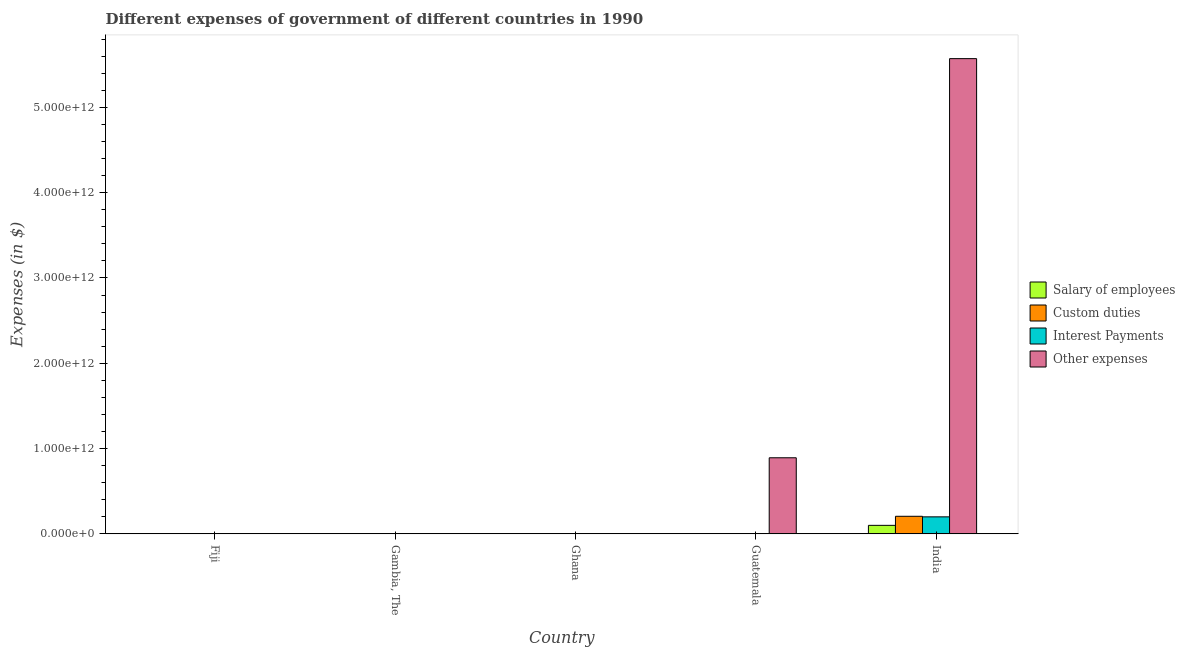How many different coloured bars are there?
Provide a succinct answer. 4. Are the number of bars per tick equal to the number of legend labels?
Offer a very short reply. Yes. How many bars are there on the 4th tick from the right?
Make the answer very short. 4. What is the label of the 1st group of bars from the left?
Offer a very short reply. Fiji. In how many cases, is the number of bars for a given country not equal to the number of legend labels?
Your answer should be very brief. 0. What is the amount spent on interest payments in Fiji?
Give a very brief answer. 6.85e+07. Across all countries, what is the maximum amount spent on salary of employees?
Keep it short and to the point. 9.97e+1. Across all countries, what is the minimum amount spent on custom duties?
Ensure brevity in your answer.  6.31e+06. In which country was the amount spent on salary of employees maximum?
Provide a short and direct response. India. What is the total amount spent on other expenses in the graph?
Your answer should be very brief. 6.47e+12. What is the difference between the amount spent on interest payments in Fiji and that in Guatemala?
Make the answer very short. -3.20e+08. What is the difference between the amount spent on interest payments in Ghana and the amount spent on custom duties in Guatemala?
Provide a succinct answer. -5.20e+08. What is the average amount spent on other expenses per country?
Your answer should be very brief. 1.29e+12. What is the difference between the amount spent on custom duties and amount spent on interest payments in Ghana?
Your answer should be very brief. 3.58e+06. What is the ratio of the amount spent on salary of employees in Fiji to that in Ghana?
Ensure brevity in your answer.  36.91. Is the difference between the amount spent on interest payments in Fiji and India greater than the difference between the amount spent on salary of employees in Fiji and India?
Ensure brevity in your answer.  No. What is the difference between the highest and the second highest amount spent on interest payments?
Your answer should be very brief. 1.99e+11. What is the difference between the highest and the lowest amount spent on interest payments?
Provide a short and direct response. 1.99e+11. Is the sum of the amount spent on other expenses in Gambia, The and Guatemala greater than the maximum amount spent on salary of employees across all countries?
Your answer should be compact. Yes. Is it the case that in every country, the sum of the amount spent on interest payments and amount spent on other expenses is greater than the sum of amount spent on salary of employees and amount spent on custom duties?
Keep it short and to the point. No. What does the 3rd bar from the left in Guatemala represents?
Offer a very short reply. Interest Payments. What does the 3rd bar from the right in India represents?
Your answer should be very brief. Custom duties. Is it the case that in every country, the sum of the amount spent on salary of employees and amount spent on custom duties is greater than the amount spent on interest payments?
Make the answer very short. Yes. Are all the bars in the graph horizontal?
Offer a very short reply. No. How many countries are there in the graph?
Offer a terse response. 5. What is the difference between two consecutive major ticks on the Y-axis?
Offer a very short reply. 1.00e+12. Are the values on the major ticks of Y-axis written in scientific E-notation?
Give a very brief answer. Yes. Does the graph contain any zero values?
Give a very brief answer. No. How many legend labels are there?
Offer a terse response. 4. What is the title of the graph?
Give a very brief answer. Different expenses of government of different countries in 1990. Does "Quality of logistic services" appear as one of the legend labels in the graph?
Provide a short and direct response. No. What is the label or title of the Y-axis?
Your answer should be compact. Expenses (in $). What is the Expenses (in $) in Salary of employees in Fiji?
Provide a short and direct response. 3.04e+08. What is the Expenses (in $) in Custom duties in Fiji?
Offer a very short reply. 1.56e+08. What is the Expenses (in $) of Interest Payments in Fiji?
Provide a succinct answer. 6.85e+07. What is the Expenses (in $) of Other expenses in Fiji?
Provide a short and direct response. 4.74e+08. What is the Expenses (in $) of Salary of employees in Gambia, The?
Your answer should be compact. 1.23e+08. What is the Expenses (in $) of Custom duties in Gambia, The?
Offer a terse response. 2.07e+08. What is the Expenses (in $) in Interest Payments in Gambia, The?
Provide a succinct answer. 9.17e+07. What is the Expenses (in $) in Other expenses in Gambia, The?
Make the answer very short. 3.88e+08. What is the Expenses (in $) of Salary of employees in Ghana?
Give a very brief answer. 8.23e+06. What is the Expenses (in $) in Custom duties in Ghana?
Make the answer very short. 6.31e+06. What is the Expenses (in $) in Interest Payments in Ghana?
Provide a succinct answer. 2.73e+06. What is the Expenses (in $) of Other expenses in Ghana?
Your response must be concise. 3.13e+09. What is the Expenses (in $) in Salary of employees in Guatemala?
Provide a short and direct response. 1.17e+09. What is the Expenses (in $) of Custom duties in Guatemala?
Offer a terse response. 5.23e+08. What is the Expenses (in $) in Interest Payments in Guatemala?
Your response must be concise. 3.89e+08. What is the Expenses (in $) of Other expenses in Guatemala?
Offer a very short reply. 8.92e+11. What is the Expenses (in $) in Salary of employees in India?
Keep it short and to the point. 9.97e+1. What is the Expenses (in $) of Custom duties in India?
Your answer should be compact. 2.06e+11. What is the Expenses (in $) of Interest Payments in India?
Provide a succinct answer. 1.99e+11. What is the Expenses (in $) in Other expenses in India?
Your response must be concise. 5.57e+12. Across all countries, what is the maximum Expenses (in $) of Salary of employees?
Provide a succinct answer. 9.97e+1. Across all countries, what is the maximum Expenses (in $) of Custom duties?
Offer a terse response. 2.06e+11. Across all countries, what is the maximum Expenses (in $) in Interest Payments?
Offer a very short reply. 1.99e+11. Across all countries, what is the maximum Expenses (in $) in Other expenses?
Provide a short and direct response. 5.57e+12. Across all countries, what is the minimum Expenses (in $) of Salary of employees?
Your answer should be very brief. 8.23e+06. Across all countries, what is the minimum Expenses (in $) in Custom duties?
Offer a very short reply. 6.31e+06. Across all countries, what is the minimum Expenses (in $) of Interest Payments?
Make the answer very short. 2.73e+06. Across all countries, what is the minimum Expenses (in $) of Other expenses?
Your response must be concise. 3.88e+08. What is the total Expenses (in $) in Salary of employees in the graph?
Your response must be concise. 1.01e+11. What is the total Expenses (in $) in Custom duties in the graph?
Make the answer very short. 2.07e+11. What is the total Expenses (in $) of Interest Payments in the graph?
Offer a very short reply. 2.00e+11. What is the total Expenses (in $) of Other expenses in the graph?
Provide a short and direct response. 6.47e+12. What is the difference between the Expenses (in $) of Salary of employees in Fiji and that in Gambia, The?
Give a very brief answer. 1.81e+08. What is the difference between the Expenses (in $) in Custom duties in Fiji and that in Gambia, The?
Ensure brevity in your answer.  -5.16e+07. What is the difference between the Expenses (in $) in Interest Payments in Fiji and that in Gambia, The?
Make the answer very short. -2.32e+07. What is the difference between the Expenses (in $) in Other expenses in Fiji and that in Gambia, The?
Your answer should be very brief. 8.61e+07. What is the difference between the Expenses (in $) of Salary of employees in Fiji and that in Ghana?
Offer a terse response. 2.96e+08. What is the difference between the Expenses (in $) in Custom duties in Fiji and that in Ghana?
Offer a terse response. 1.49e+08. What is the difference between the Expenses (in $) in Interest Payments in Fiji and that in Ghana?
Your answer should be compact. 6.58e+07. What is the difference between the Expenses (in $) of Other expenses in Fiji and that in Ghana?
Offer a terse response. -2.66e+09. What is the difference between the Expenses (in $) in Salary of employees in Fiji and that in Guatemala?
Your answer should be very brief. -8.68e+08. What is the difference between the Expenses (in $) in Custom duties in Fiji and that in Guatemala?
Offer a very short reply. -3.67e+08. What is the difference between the Expenses (in $) in Interest Payments in Fiji and that in Guatemala?
Your answer should be compact. -3.20e+08. What is the difference between the Expenses (in $) in Other expenses in Fiji and that in Guatemala?
Your answer should be compact. -8.92e+11. What is the difference between the Expenses (in $) of Salary of employees in Fiji and that in India?
Your answer should be very brief. -9.94e+1. What is the difference between the Expenses (in $) of Custom duties in Fiji and that in India?
Your response must be concise. -2.06e+11. What is the difference between the Expenses (in $) in Interest Payments in Fiji and that in India?
Offer a very short reply. -1.99e+11. What is the difference between the Expenses (in $) of Other expenses in Fiji and that in India?
Provide a succinct answer. -5.57e+12. What is the difference between the Expenses (in $) of Salary of employees in Gambia, The and that in Ghana?
Offer a very short reply. 1.15e+08. What is the difference between the Expenses (in $) in Custom duties in Gambia, The and that in Ghana?
Make the answer very short. 2.01e+08. What is the difference between the Expenses (in $) of Interest Payments in Gambia, The and that in Ghana?
Offer a very short reply. 8.90e+07. What is the difference between the Expenses (in $) of Other expenses in Gambia, The and that in Ghana?
Ensure brevity in your answer.  -2.75e+09. What is the difference between the Expenses (in $) in Salary of employees in Gambia, The and that in Guatemala?
Make the answer very short. -1.05e+09. What is the difference between the Expenses (in $) of Custom duties in Gambia, The and that in Guatemala?
Your answer should be very brief. -3.16e+08. What is the difference between the Expenses (in $) in Interest Payments in Gambia, The and that in Guatemala?
Provide a succinct answer. -2.97e+08. What is the difference between the Expenses (in $) of Other expenses in Gambia, The and that in Guatemala?
Provide a succinct answer. -8.92e+11. What is the difference between the Expenses (in $) of Salary of employees in Gambia, The and that in India?
Keep it short and to the point. -9.96e+1. What is the difference between the Expenses (in $) of Custom duties in Gambia, The and that in India?
Ensure brevity in your answer.  -2.06e+11. What is the difference between the Expenses (in $) in Interest Payments in Gambia, The and that in India?
Your answer should be compact. -1.99e+11. What is the difference between the Expenses (in $) of Other expenses in Gambia, The and that in India?
Your answer should be very brief. -5.57e+12. What is the difference between the Expenses (in $) of Salary of employees in Ghana and that in Guatemala?
Give a very brief answer. -1.16e+09. What is the difference between the Expenses (in $) in Custom duties in Ghana and that in Guatemala?
Offer a terse response. -5.17e+08. What is the difference between the Expenses (in $) in Interest Payments in Ghana and that in Guatemala?
Give a very brief answer. -3.86e+08. What is the difference between the Expenses (in $) in Other expenses in Ghana and that in Guatemala?
Make the answer very short. -8.89e+11. What is the difference between the Expenses (in $) in Salary of employees in Ghana and that in India?
Keep it short and to the point. -9.97e+1. What is the difference between the Expenses (in $) of Custom duties in Ghana and that in India?
Keep it short and to the point. -2.06e+11. What is the difference between the Expenses (in $) in Interest Payments in Ghana and that in India?
Give a very brief answer. -1.99e+11. What is the difference between the Expenses (in $) in Other expenses in Ghana and that in India?
Provide a short and direct response. -5.57e+12. What is the difference between the Expenses (in $) in Salary of employees in Guatemala and that in India?
Your response must be concise. -9.85e+1. What is the difference between the Expenses (in $) in Custom duties in Guatemala and that in India?
Your answer should be very brief. -2.06e+11. What is the difference between the Expenses (in $) in Interest Payments in Guatemala and that in India?
Your response must be concise. -1.99e+11. What is the difference between the Expenses (in $) in Other expenses in Guatemala and that in India?
Your answer should be compact. -4.68e+12. What is the difference between the Expenses (in $) in Salary of employees in Fiji and the Expenses (in $) in Custom duties in Gambia, The?
Your answer should be compact. 9.65e+07. What is the difference between the Expenses (in $) of Salary of employees in Fiji and the Expenses (in $) of Interest Payments in Gambia, The?
Offer a very short reply. 2.12e+08. What is the difference between the Expenses (in $) in Salary of employees in Fiji and the Expenses (in $) in Other expenses in Gambia, The?
Provide a succinct answer. -8.45e+07. What is the difference between the Expenses (in $) of Custom duties in Fiji and the Expenses (in $) of Interest Payments in Gambia, The?
Offer a terse response. 6.38e+07. What is the difference between the Expenses (in $) of Custom duties in Fiji and the Expenses (in $) of Other expenses in Gambia, The?
Offer a terse response. -2.33e+08. What is the difference between the Expenses (in $) in Interest Payments in Fiji and the Expenses (in $) in Other expenses in Gambia, The?
Offer a terse response. -3.20e+08. What is the difference between the Expenses (in $) in Salary of employees in Fiji and the Expenses (in $) in Custom duties in Ghana?
Provide a short and direct response. 2.97e+08. What is the difference between the Expenses (in $) in Salary of employees in Fiji and the Expenses (in $) in Interest Payments in Ghana?
Give a very brief answer. 3.01e+08. What is the difference between the Expenses (in $) of Salary of employees in Fiji and the Expenses (in $) of Other expenses in Ghana?
Provide a short and direct response. -2.83e+09. What is the difference between the Expenses (in $) in Custom duties in Fiji and the Expenses (in $) in Interest Payments in Ghana?
Your answer should be compact. 1.53e+08. What is the difference between the Expenses (in $) in Custom duties in Fiji and the Expenses (in $) in Other expenses in Ghana?
Make the answer very short. -2.98e+09. What is the difference between the Expenses (in $) of Interest Payments in Fiji and the Expenses (in $) of Other expenses in Ghana?
Offer a very short reply. -3.07e+09. What is the difference between the Expenses (in $) in Salary of employees in Fiji and the Expenses (in $) in Custom duties in Guatemala?
Ensure brevity in your answer.  -2.19e+08. What is the difference between the Expenses (in $) of Salary of employees in Fiji and the Expenses (in $) of Interest Payments in Guatemala?
Offer a terse response. -8.52e+07. What is the difference between the Expenses (in $) in Salary of employees in Fiji and the Expenses (in $) in Other expenses in Guatemala?
Ensure brevity in your answer.  -8.92e+11. What is the difference between the Expenses (in $) in Custom duties in Fiji and the Expenses (in $) in Interest Payments in Guatemala?
Offer a very short reply. -2.33e+08. What is the difference between the Expenses (in $) in Custom duties in Fiji and the Expenses (in $) in Other expenses in Guatemala?
Provide a short and direct response. -8.92e+11. What is the difference between the Expenses (in $) in Interest Payments in Fiji and the Expenses (in $) in Other expenses in Guatemala?
Offer a terse response. -8.92e+11. What is the difference between the Expenses (in $) in Salary of employees in Fiji and the Expenses (in $) in Custom duties in India?
Give a very brief answer. -2.06e+11. What is the difference between the Expenses (in $) of Salary of employees in Fiji and the Expenses (in $) of Interest Payments in India?
Your answer should be compact. -1.99e+11. What is the difference between the Expenses (in $) of Salary of employees in Fiji and the Expenses (in $) of Other expenses in India?
Keep it short and to the point. -5.57e+12. What is the difference between the Expenses (in $) in Custom duties in Fiji and the Expenses (in $) in Interest Payments in India?
Ensure brevity in your answer.  -1.99e+11. What is the difference between the Expenses (in $) of Custom duties in Fiji and the Expenses (in $) of Other expenses in India?
Keep it short and to the point. -5.57e+12. What is the difference between the Expenses (in $) of Interest Payments in Fiji and the Expenses (in $) of Other expenses in India?
Provide a short and direct response. -5.57e+12. What is the difference between the Expenses (in $) in Salary of employees in Gambia, The and the Expenses (in $) in Custom duties in Ghana?
Keep it short and to the point. 1.17e+08. What is the difference between the Expenses (in $) of Salary of employees in Gambia, The and the Expenses (in $) of Interest Payments in Ghana?
Provide a short and direct response. 1.20e+08. What is the difference between the Expenses (in $) in Salary of employees in Gambia, The and the Expenses (in $) in Other expenses in Ghana?
Provide a short and direct response. -3.01e+09. What is the difference between the Expenses (in $) in Custom duties in Gambia, The and the Expenses (in $) in Interest Payments in Ghana?
Keep it short and to the point. 2.04e+08. What is the difference between the Expenses (in $) of Custom duties in Gambia, The and the Expenses (in $) of Other expenses in Ghana?
Give a very brief answer. -2.93e+09. What is the difference between the Expenses (in $) in Interest Payments in Gambia, The and the Expenses (in $) in Other expenses in Ghana?
Make the answer very short. -3.04e+09. What is the difference between the Expenses (in $) in Salary of employees in Gambia, The and the Expenses (in $) in Custom duties in Guatemala?
Your answer should be compact. -4.00e+08. What is the difference between the Expenses (in $) in Salary of employees in Gambia, The and the Expenses (in $) in Interest Payments in Guatemala?
Offer a terse response. -2.66e+08. What is the difference between the Expenses (in $) in Salary of employees in Gambia, The and the Expenses (in $) in Other expenses in Guatemala?
Ensure brevity in your answer.  -8.92e+11. What is the difference between the Expenses (in $) of Custom duties in Gambia, The and the Expenses (in $) of Interest Payments in Guatemala?
Offer a very short reply. -1.82e+08. What is the difference between the Expenses (in $) of Custom duties in Gambia, The and the Expenses (in $) of Other expenses in Guatemala?
Ensure brevity in your answer.  -8.92e+11. What is the difference between the Expenses (in $) of Interest Payments in Gambia, The and the Expenses (in $) of Other expenses in Guatemala?
Offer a very short reply. -8.92e+11. What is the difference between the Expenses (in $) in Salary of employees in Gambia, The and the Expenses (in $) in Custom duties in India?
Ensure brevity in your answer.  -2.06e+11. What is the difference between the Expenses (in $) of Salary of employees in Gambia, The and the Expenses (in $) of Interest Payments in India?
Keep it short and to the point. -1.99e+11. What is the difference between the Expenses (in $) in Salary of employees in Gambia, The and the Expenses (in $) in Other expenses in India?
Give a very brief answer. -5.57e+12. What is the difference between the Expenses (in $) of Custom duties in Gambia, The and the Expenses (in $) of Interest Payments in India?
Keep it short and to the point. -1.99e+11. What is the difference between the Expenses (in $) of Custom duties in Gambia, The and the Expenses (in $) of Other expenses in India?
Keep it short and to the point. -5.57e+12. What is the difference between the Expenses (in $) of Interest Payments in Gambia, The and the Expenses (in $) of Other expenses in India?
Your answer should be very brief. -5.57e+12. What is the difference between the Expenses (in $) of Salary of employees in Ghana and the Expenses (in $) of Custom duties in Guatemala?
Make the answer very short. -5.15e+08. What is the difference between the Expenses (in $) in Salary of employees in Ghana and the Expenses (in $) in Interest Payments in Guatemala?
Your answer should be very brief. -3.81e+08. What is the difference between the Expenses (in $) in Salary of employees in Ghana and the Expenses (in $) in Other expenses in Guatemala?
Offer a very short reply. -8.92e+11. What is the difference between the Expenses (in $) of Custom duties in Ghana and the Expenses (in $) of Interest Payments in Guatemala?
Give a very brief answer. -3.83e+08. What is the difference between the Expenses (in $) in Custom duties in Ghana and the Expenses (in $) in Other expenses in Guatemala?
Offer a very short reply. -8.92e+11. What is the difference between the Expenses (in $) in Interest Payments in Ghana and the Expenses (in $) in Other expenses in Guatemala?
Give a very brief answer. -8.92e+11. What is the difference between the Expenses (in $) in Salary of employees in Ghana and the Expenses (in $) in Custom duties in India?
Keep it short and to the point. -2.06e+11. What is the difference between the Expenses (in $) of Salary of employees in Ghana and the Expenses (in $) of Interest Payments in India?
Your answer should be very brief. -1.99e+11. What is the difference between the Expenses (in $) of Salary of employees in Ghana and the Expenses (in $) of Other expenses in India?
Offer a terse response. -5.57e+12. What is the difference between the Expenses (in $) of Custom duties in Ghana and the Expenses (in $) of Interest Payments in India?
Make the answer very short. -1.99e+11. What is the difference between the Expenses (in $) of Custom duties in Ghana and the Expenses (in $) of Other expenses in India?
Offer a very short reply. -5.57e+12. What is the difference between the Expenses (in $) in Interest Payments in Ghana and the Expenses (in $) in Other expenses in India?
Offer a terse response. -5.57e+12. What is the difference between the Expenses (in $) in Salary of employees in Guatemala and the Expenses (in $) in Custom duties in India?
Keep it short and to the point. -2.05e+11. What is the difference between the Expenses (in $) in Salary of employees in Guatemala and the Expenses (in $) in Interest Payments in India?
Keep it short and to the point. -1.98e+11. What is the difference between the Expenses (in $) of Salary of employees in Guatemala and the Expenses (in $) of Other expenses in India?
Keep it short and to the point. -5.57e+12. What is the difference between the Expenses (in $) in Custom duties in Guatemala and the Expenses (in $) in Interest Payments in India?
Ensure brevity in your answer.  -1.99e+11. What is the difference between the Expenses (in $) in Custom duties in Guatemala and the Expenses (in $) in Other expenses in India?
Provide a succinct answer. -5.57e+12. What is the difference between the Expenses (in $) of Interest Payments in Guatemala and the Expenses (in $) of Other expenses in India?
Give a very brief answer. -5.57e+12. What is the average Expenses (in $) of Salary of employees per country?
Keep it short and to the point. 2.03e+1. What is the average Expenses (in $) of Custom duties per country?
Ensure brevity in your answer.  4.14e+1. What is the average Expenses (in $) of Interest Payments per country?
Offer a terse response. 4.00e+1. What is the average Expenses (in $) in Other expenses per country?
Your response must be concise. 1.29e+12. What is the difference between the Expenses (in $) of Salary of employees and Expenses (in $) of Custom duties in Fiji?
Your response must be concise. 1.48e+08. What is the difference between the Expenses (in $) in Salary of employees and Expenses (in $) in Interest Payments in Fiji?
Your answer should be compact. 2.35e+08. What is the difference between the Expenses (in $) of Salary of employees and Expenses (in $) of Other expenses in Fiji?
Ensure brevity in your answer.  -1.71e+08. What is the difference between the Expenses (in $) in Custom duties and Expenses (in $) in Interest Payments in Fiji?
Your answer should be compact. 8.71e+07. What is the difference between the Expenses (in $) in Custom duties and Expenses (in $) in Other expenses in Fiji?
Your answer should be very brief. -3.19e+08. What is the difference between the Expenses (in $) of Interest Payments and Expenses (in $) of Other expenses in Fiji?
Keep it short and to the point. -4.06e+08. What is the difference between the Expenses (in $) in Salary of employees and Expenses (in $) in Custom duties in Gambia, The?
Provide a succinct answer. -8.43e+07. What is the difference between the Expenses (in $) of Salary of employees and Expenses (in $) of Interest Payments in Gambia, The?
Provide a short and direct response. 3.12e+07. What is the difference between the Expenses (in $) of Salary of employees and Expenses (in $) of Other expenses in Gambia, The?
Your answer should be very brief. -2.65e+08. What is the difference between the Expenses (in $) of Custom duties and Expenses (in $) of Interest Payments in Gambia, The?
Make the answer very short. 1.16e+08. What is the difference between the Expenses (in $) of Custom duties and Expenses (in $) of Other expenses in Gambia, The?
Give a very brief answer. -1.81e+08. What is the difference between the Expenses (in $) in Interest Payments and Expenses (in $) in Other expenses in Gambia, The?
Your response must be concise. -2.96e+08. What is the difference between the Expenses (in $) in Salary of employees and Expenses (in $) in Custom duties in Ghana?
Provide a succinct answer. 1.91e+06. What is the difference between the Expenses (in $) in Salary of employees and Expenses (in $) in Interest Payments in Ghana?
Your response must be concise. 5.50e+06. What is the difference between the Expenses (in $) in Salary of employees and Expenses (in $) in Other expenses in Ghana?
Offer a very short reply. -3.13e+09. What is the difference between the Expenses (in $) of Custom duties and Expenses (in $) of Interest Payments in Ghana?
Offer a very short reply. 3.58e+06. What is the difference between the Expenses (in $) of Custom duties and Expenses (in $) of Other expenses in Ghana?
Offer a very short reply. -3.13e+09. What is the difference between the Expenses (in $) of Interest Payments and Expenses (in $) of Other expenses in Ghana?
Your response must be concise. -3.13e+09. What is the difference between the Expenses (in $) of Salary of employees and Expenses (in $) of Custom duties in Guatemala?
Ensure brevity in your answer.  6.49e+08. What is the difference between the Expenses (in $) in Salary of employees and Expenses (in $) in Interest Payments in Guatemala?
Offer a very short reply. 7.83e+08. What is the difference between the Expenses (in $) in Salary of employees and Expenses (in $) in Other expenses in Guatemala?
Make the answer very short. -8.91e+11. What is the difference between the Expenses (in $) of Custom duties and Expenses (in $) of Interest Payments in Guatemala?
Offer a terse response. 1.34e+08. What is the difference between the Expenses (in $) of Custom duties and Expenses (in $) of Other expenses in Guatemala?
Your response must be concise. -8.92e+11. What is the difference between the Expenses (in $) in Interest Payments and Expenses (in $) in Other expenses in Guatemala?
Your response must be concise. -8.92e+11. What is the difference between the Expenses (in $) in Salary of employees and Expenses (in $) in Custom duties in India?
Offer a terse response. -1.06e+11. What is the difference between the Expenses (in $) in Salary of employees and Expenses (in $) in Interest Payments in India?
Provide a short and direct response. -9.98e+1. What is the difference between the Expenses (in $) in Salary of employees and Expenses (in $) in Other expenses in India?
Provide a succinct answer. -5.47e+12. What is the difference between the Expenses (in $) in Custom duties and Expenses (in $) in Interest Payments in India?
Offer a terse response. 6.60e+09. What is the difference between the Expenses (in $) of Custom duties and Expenses (in $) of Other expenses in India?
Ensure brevity in your answer.  -5.37e+12. What is the difference between the Expenses (in $) of Interest Payments and Expenses (in $) of Other expenses in India?
Provide a short and direct response. -5.37e+12. What is the ratio of the Expenses (in $) in Salary of employees in Fiji to that in Gambia, The?
Ensure brevity in your answer.  2.47. What is the ratio of the Expenses (in $) in Custom duties in Fiji to that in Gambia, The?
Your answer should be compact. 0.75. What is the ratio of the Expenses (in $) of Interest Payments in Fiji to that in Gambia, The?
Your answer should be very brief. 0.75. What is the ratio of the Expenses (in $) of Other expenses in Fiji to that in Gambia, The?
Keep it short and to the point. 1.22. What is the ratio of the Expenses (in $) in Salary of employees in Fiji to that in Ghana?
Provide a succinct answer. 36.91. What is the ratio of the Expenses (in $) of Custom duties in Fiji to that in Ghana?
Provide a succinct answer. 24.64. What is the ratio of the Expenses (in $) of Interest Payments in Fiji to that in Ghana?
Provide a succinct answer. 25.08. What is the ratio of the Expenses (in $) in Other expenses in Fiji to that in Ghana?
Your answer should be very brief. 0.15. What is the ratio of the Expenses (in $) in Salary of employees in Fiji to that in Guatemala?
Offer a terse response. 0.26. What is the ratio of the Expenses (in $) of Custom duties in Fiji to that in Guatemala?
Offer a terse response. 0.3. What is the ratio of the Expenses (in $) of Interest Payments in Fiji to that in Guatemala?
Your answer should be very brief. 0.18. What is the ratio of the Expenses (in $) in Other expenses in Fiji to that in Guatemala?
Give a very brief answer. 0. What is the ratio of the Expenses (in $) in Salary of employees in Fiji to that in India?
Your answer should be very brief. 0. What is the ratio of the Expenses (in $) in Custom duties in Fiji to that in India?
Offer a terse response. 0. What is the ratio of the Expenses (in $) in Interest Payments in Fiji to that in India?
Offer a terse response. 0. What is the ratio of the Expenses (in $) of Other expenses in Fiji to that in India?
Your answer should be very brief. 0. What is the ratio of the Expenses (in $) of Salary of employees in Gambia, The to that in Ghana?
Provide a short and direct response. 14.94. What is the ratio of the Expenses (in $) in Custom duties in Gambia, The to that in Ghana?
Your response must be concise. 32.82. What is the ratio of the Expenses (in $) in Interest Payments in Gambia, The to that in Ghana?
Provide a short and direct response. 33.57. What is the ratio of the Expenses (in $) in Other expenses in Gambia, The to that in Ghana?
Keep it short and to the point. 0.12. What is the ratio of the Expenses (in $) in Salary of employees in Gambia, The to that in Guatemala?
Give a very brief answer. 0.1. What is the ratio of the Expenses (in $) in Custom duties in Gambia, The to that in Guatemala?
Provide a short and direct response. 0.4. What is the ratio of the Expenses (in $) in Interest Payments in Gambia, The to that in Guatemala?
Give a very brief answer. 0.24. What is the ratio of the Expenses (in $) of Other expenses in Gambia, The to that in Guatemala?
Make the answer very short. 0. What is the ratio of the Expenses (in $) in Salary of employees in Gambia, The to that in India?
Provide a succinct answer. 0. What is the ratio of the Expenses (in $) in Custom duties in Gambia, The to that in India?
Your answer should be very brief. 0. What is the ratio of the Expenses (in $) in Interest Payments in Gambia, The to that in India?
Make the answer very short. 0. What is the ratio of the Expenses (in $) of Salary of employees in Ghana to that in Guatemala?
Offer a terse response. 0.01. What is the ratio of the Expenses (in $) of Custom duties in Ghana to that in Guatemala?
Provide a short and direct response. 0.01. What is the ratio of the Expenses (in $) of Interest Payments in Ghana to that in Guatemala?
Your answer should be very brief. 0.01. What is the ratio of the Expenses (in $) of Other expenses in Ghana to that in Guatemala?
Offer a terse response. 0. What is the ratio of the Expenses (in $) of Salary of employees in Ghana to that in India?
Your answer should be compact. 0. What is the ratio of the Expenses (in $) of Custom duties in Ghana to that in India?
Keep it short and to the point. 0. What is the ratio of the Expenses (in $) of Other expenses in Ghana to that in India?
Keep it short and to the point. 0. What is the ratio of the Expenses (in $) of Salary of employees in Guatemala to that in India?
Give a very brief answer. 0.01. What is the ratio of the Expenses (in $) of Custom duties in Guatemala to that in India?
Make the answer very short. 0. What is the ratio of the Expenses (in $) of Interest Payments in Guatemala to that in India?
Keep it short and to the point. 0. What is the ratio of the Expenses (in $) in Other expenses in Guatemala to that in India?
Your response must be concise. 0.16. What is the difference between the highest and the second highest Expenses (in $) of Salary of employees?
Your answer should be compact. 9.85e+1. What is the difference between the highest and the second highest Expenses (in $) in Custom duties?
Your answer should be compact. 2.06e+11. What is the difference between the highest and the second highest Expenses (in $) of Interest Payments?
Offer a terse response. 1.99e+11. What is the difference between the highest and the second highest Expenses (in $) of Other expenses?
Ensure brevity in your answer.  4.68e+12. What is the difference between the highest and the lowest Expenses (in $) of Salary of employees?
Offer a very short reply. 9.97e+1. What is the difference between the highest and the lowest Expenses (in $) in Custom duties?
Give a very brief answer. 2.06e+11. What is the difference between the highest and the lowest Expenses (in $) in Interest Payments?
Your answer should be compact. 1.99e+11. What is the difference between the highest and the lowest Expenses (in $) of Other expenses?
Provide a succinct answer. 5.57e+12. 